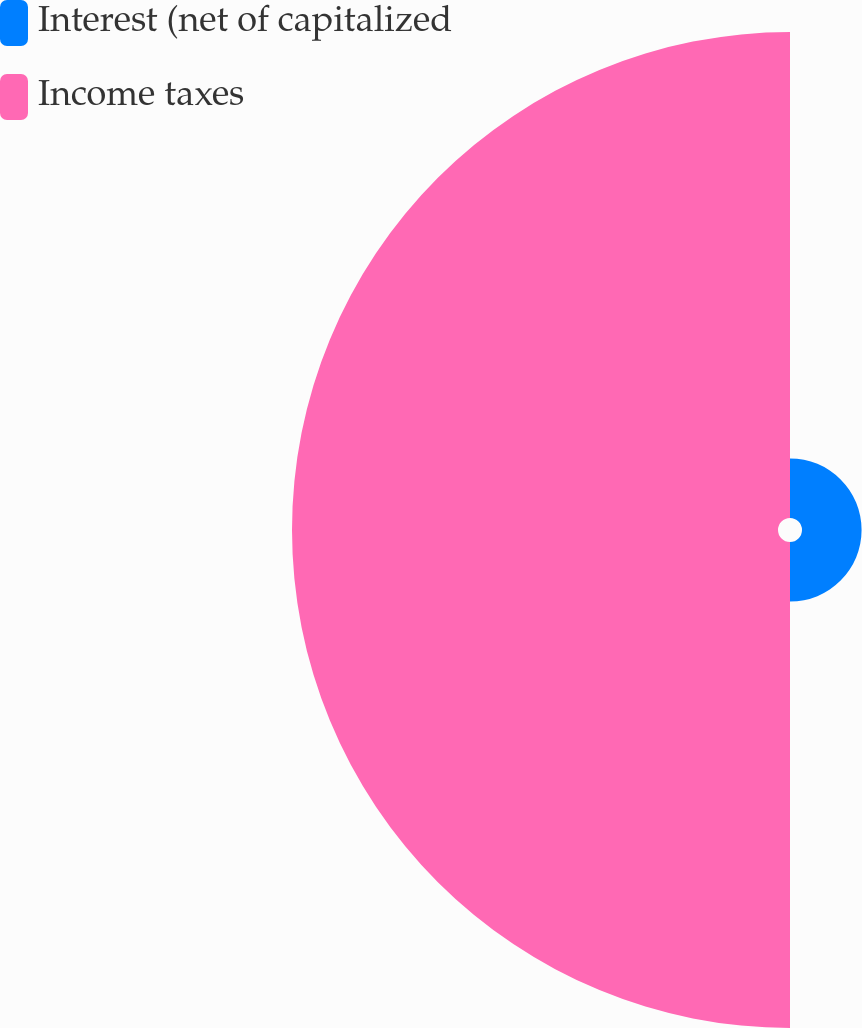Convert chart. <chart><loc_0><loc_0><loc_500><loc_500><pie_chart><fcel>Interest (net of capitalized<fcel>Income taxes<nl><fcel>10.92%<fcel>89.08%<nl></chart> 